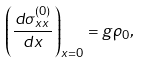<formula> <loc_0><loc_0><loc_500><loc_500>\left ( \frac { d \sigma _ { x x } ^ { ( 0 ) } } { d x } \right ) _ { x = 0 } = g \rho _ { 0 } ,</formula> 